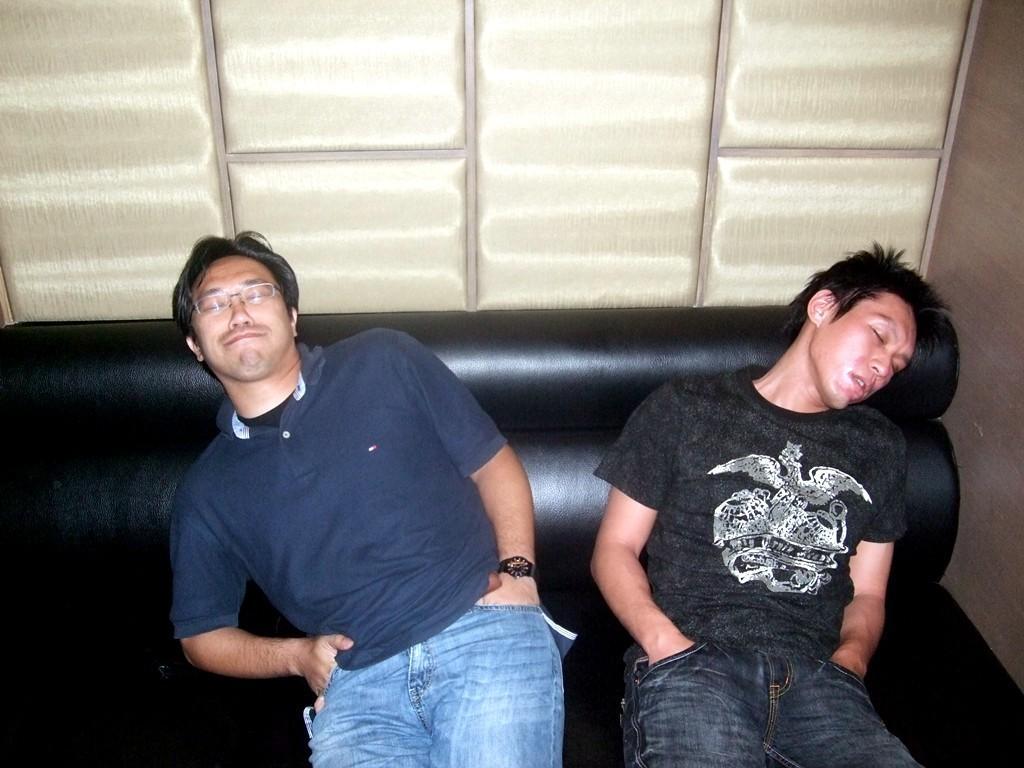Describe this image in one or two sentences. In this image we can see two persons sleeping on the sofa. In the background we can see the wall. 